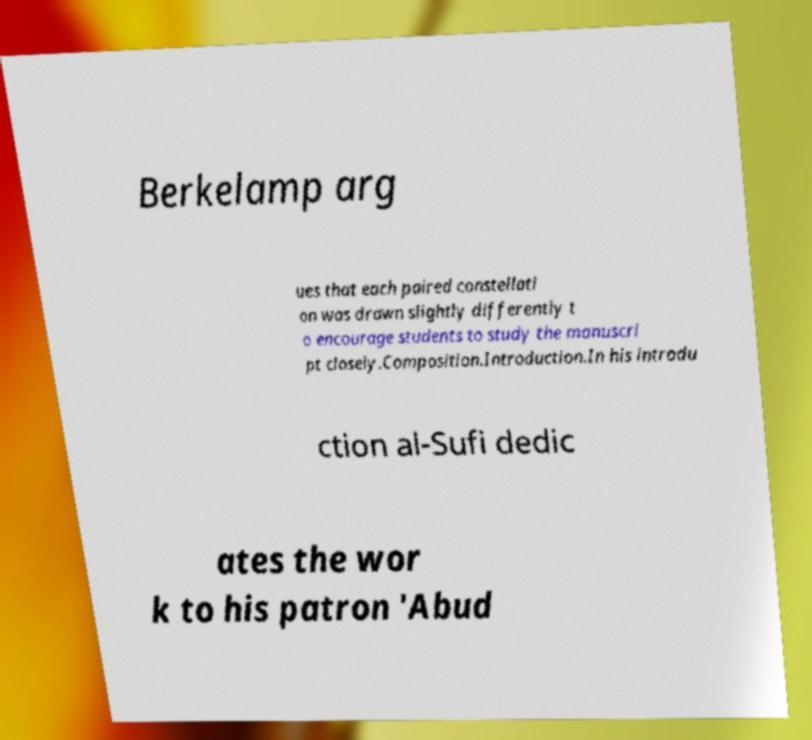There's text embedded in this image that I need extracted. Can you transcribe it verbatim? Berkelamp arg ues that each paired constellati on was drawn slightly differently t o encourage students to study the manuscri pt closely.Composition.Introduction.In his introdu ction al-Sufi dedic ates the wor k to his patron 'Abud 